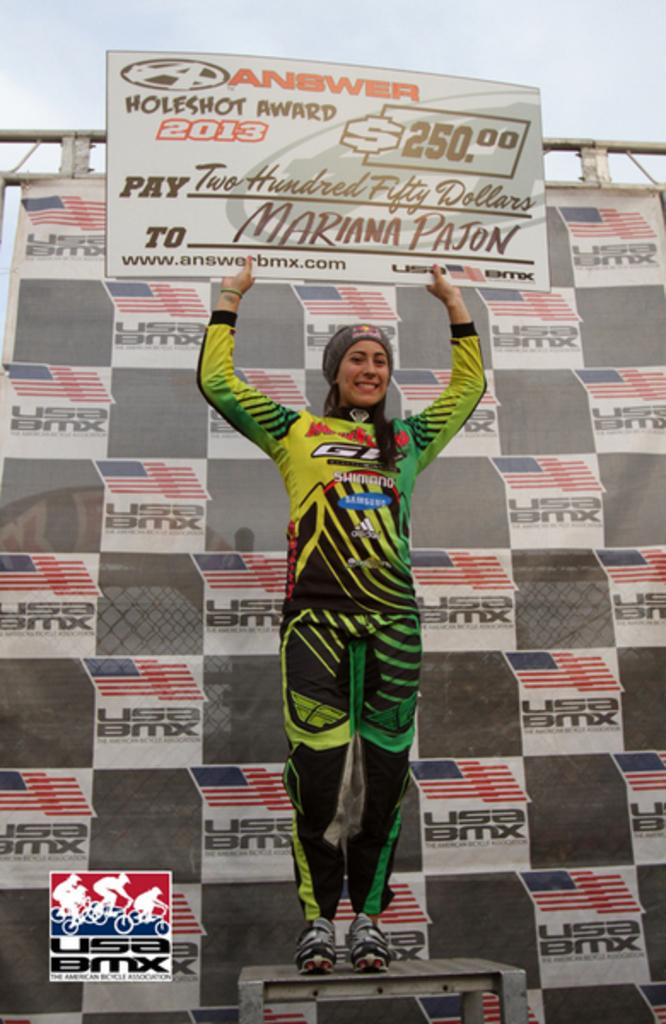Who is the main subject in the image? There is a woman in the image. What is the woman doing in the image? The woman is standing on a dais and holding a prize with both hands. What else can be seen in the image related to the event? There is a banner of the event in the image. What type of protest is the woman leading in the image? There is no protest present in the image; the woman is standing on a dais holding a prize. What kind of property does the woman own in the image? There is no property mentioned or depicted in the image; it features a woman holding a prize on a dais. 